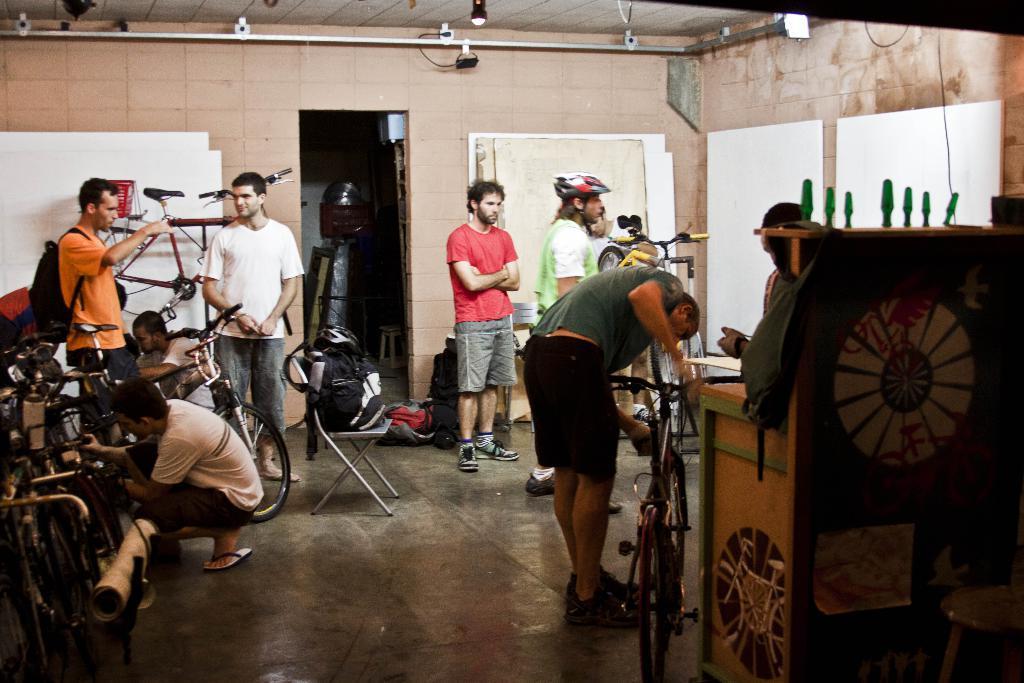Please provide a concise description of this image. The picture is taken in a closed room where there are people nearly ten members and coming to the right corner of the picture there is one wooden stand on which the bag is kept and one person is standing and checking his bicycle and behind him there are three more people and one person is wearing a helmet and another person is wearing red shirt and, beside him there is a chair and a bag on it, behind the chair there are some bags,chairs and some stuff in the room and coming to the left corner of the picture there is one person sitting on the floor and looking some thing in the bicycle,behind him there is one person standing in orange shirt and wearing a bag and in front of him there is another person standing in a white shirt and behind him there is a cycle hanged to the wall. 